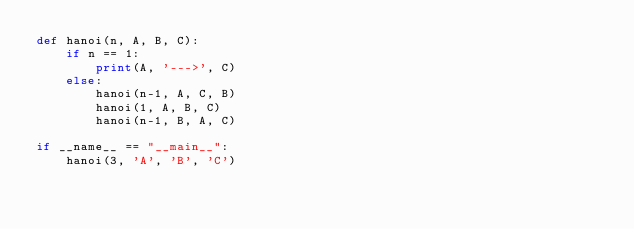Convert code to text. <code><loc_0><loc_0><loc_500><loc_500><_Python_>def hanoi(n, A, B, C):
    if n == 1:
        print(A, '--->', C)
    else:
        hanoi(n-1, A, C, B)
        hanoi(1, A, B, C)
        hanoi(n-1, B, A, C)

if __name__ == "__main__":
    hanoi(3, 'A', 'B', 'C')
</code> 